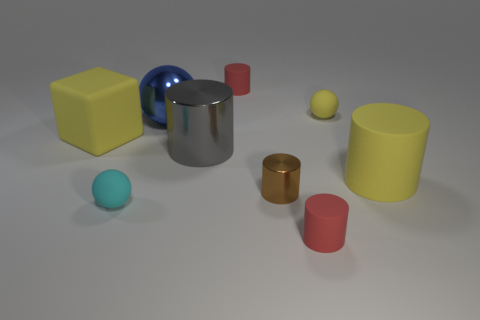Subtract all yellow balls. How many red cylinders are left? 2 Subtract all blue metallic balls. How many balls are left? 2 Subtract 2 cylinders. How many cylinders are left? 3 Add 1 red matte cylinders. How many objects exist? 10 Subtract all yellow cylinders. How many cylinders are left? 4 Subtract all cylinders. How many objects are left? 4 Subtract all brown spheres. Subtract all yellow cylinders. How many spheres are left? 3 Subtract all tiny rubber spheres. Subtract all big matte objects. How many objects are left? 5 Add 3 blue metal spheres. How many blue metal spheres are left? 4 Add 9 big gray rubber things. How many big gray rubber things exist? 9 